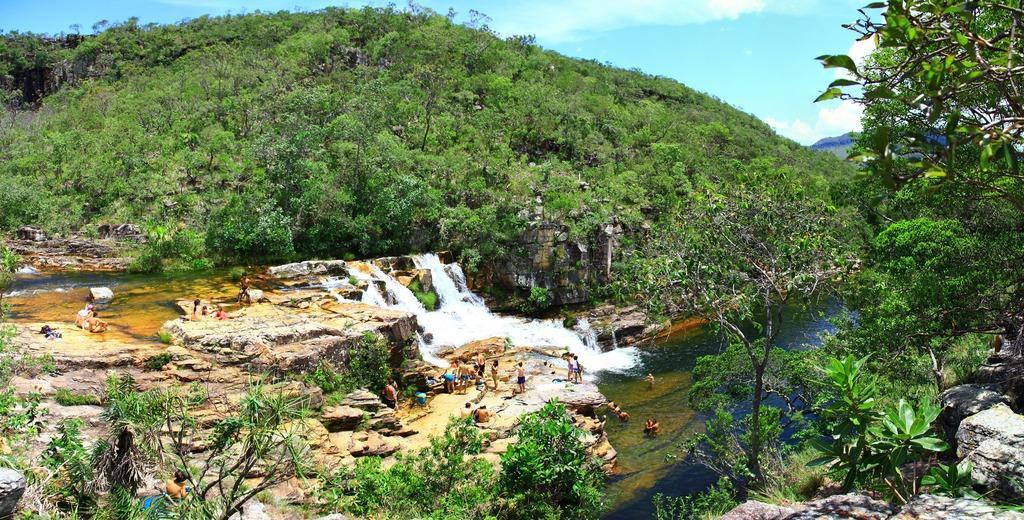Please provide a concise description of this image. This picture shows water flowing and we see few people standing and few are seated on the rocks and we see trees and a blue cloudy sky and we see few people swimming in the water. 